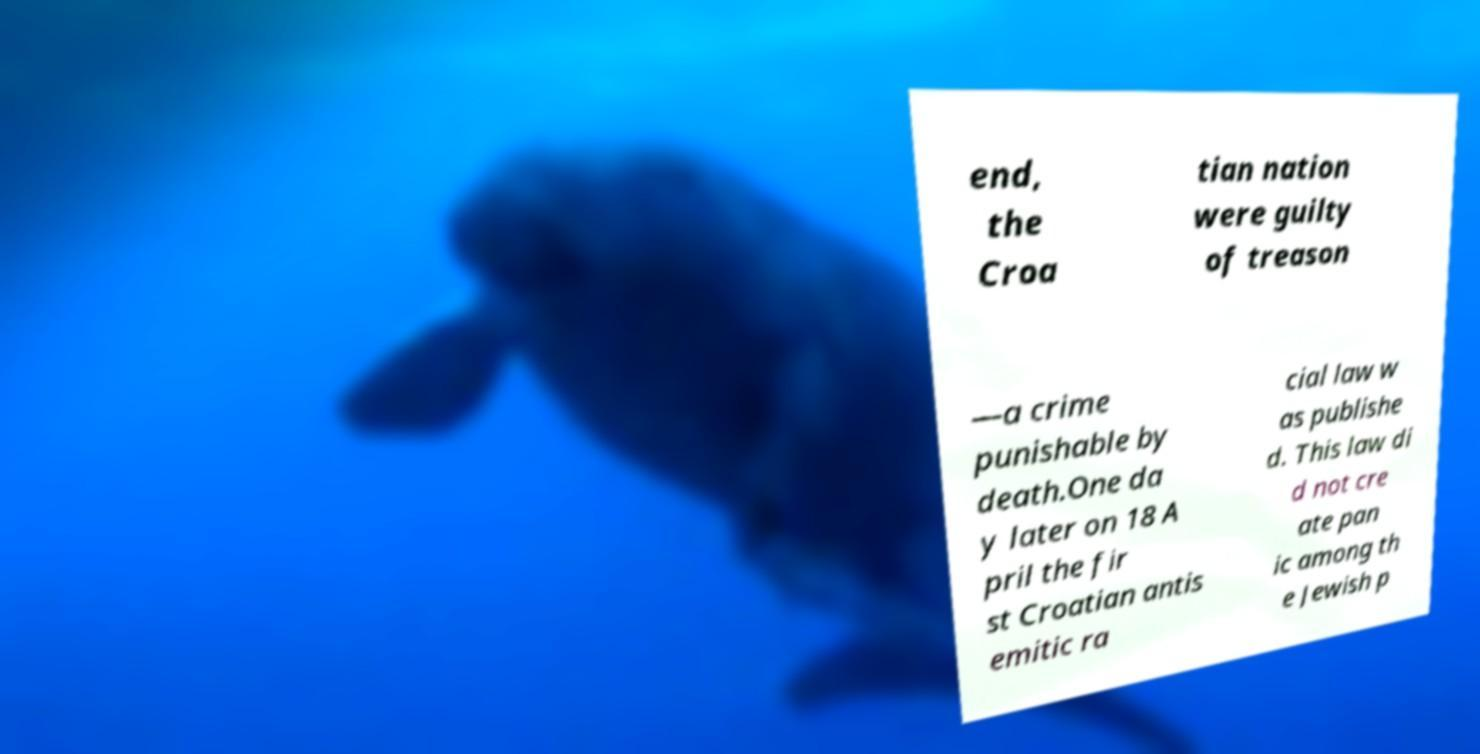Could you extract and type out the text from this image? end, the Croa tian nation were guilty of treason —a crime punishable by death.One da y later on 18 A pril the fir st Croatian antis emitic ra cial law w as publishe d. This law di d not cre ate pan ic among th e Jewish p 